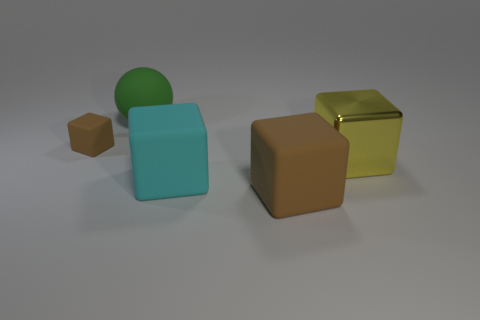Is there anything else that has the same material as the cyan cube?
Your answer should be very brief. Yes. Does the cyan rubber thing have the same size as the brown rubber thing that is to the left of the green matte object?
Make the answer very short. No. What is the cyan object that is behind the brown rubber block in front of the yellow metal block made of?
Provide a short and direct response. Rubber. Is the number of cyan objects to the right of the big brown rubber thing the same as the number of green things?
Give a very brief answer. No. There is a block that is both behind the cyan object and on the right side of the matte ball; how big is it?
Give a very brief answer. Large. There is a tiny block behind the brown matte cube in front of the tiny brown cube; what is its color?
Make the answer very short. Brown. Are there the same number of big metal cubes and large purple things?
Provide a succinct answer. No. What number of red objects are big shiny things or large matte blocks?
Your answer should be compact. 0. What is the color of the matte block that is both behind the large brown cube and to the right of the green sphere?
Give a very brief answer. Cyan. How many big objects are either red blocks or green rubber balls?
Your answer should be compact. 1. 